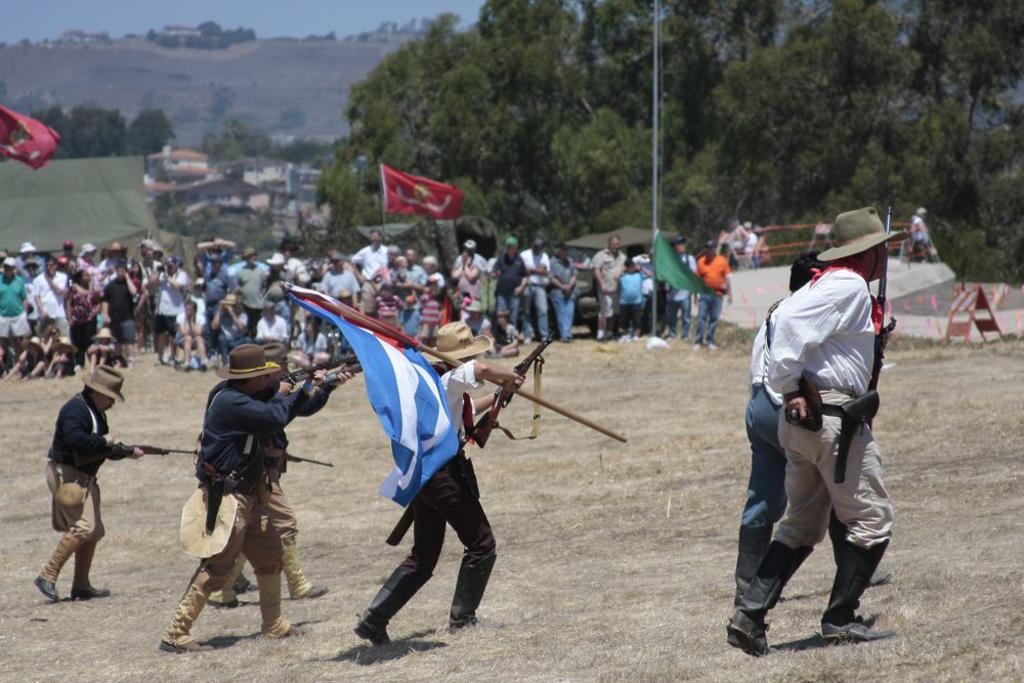Please provide a concise description of this image. In this image I can see few persons holding weapons. In the background there are few people. I can see few trees. 